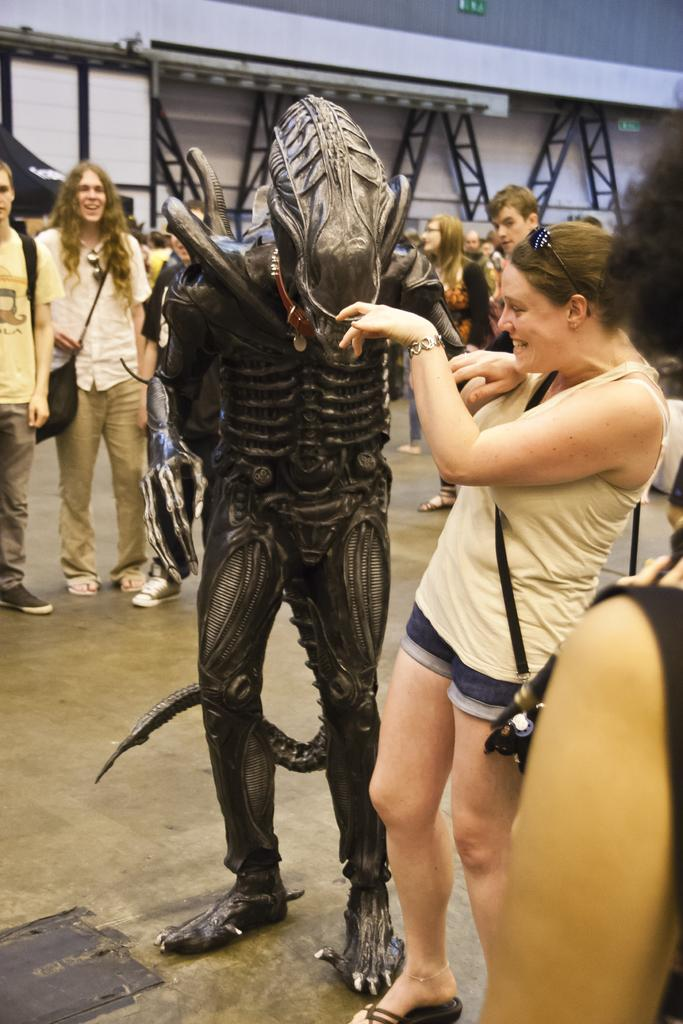How many people are in the image? There is a group of people in the image. Can you describe the attire of one of the individuals? One person is wearing a costume. What can be seen in the background of the image? There are metal rods visible in the background of the image. What type of branch can be seen growing from the person's head in the image? There is no branch growing from anyone's head in the image. 